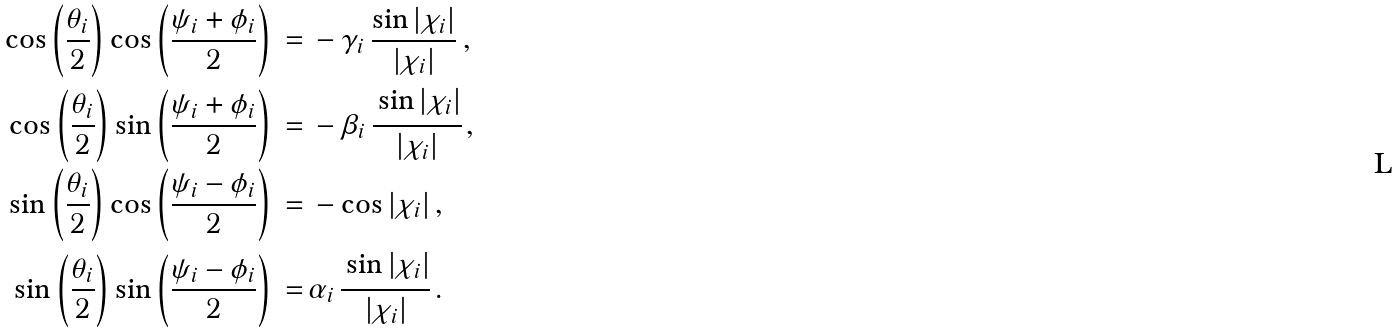<formula> <loc_0><loc_0><loc_500><loc_500>\cos \left ( \frac { \theta _ { i } } { 2 } \right ) \cos \left ( \frac { \psi _ { i } + \phi _ { i } } { 2 } \right ) \, = & \, - \gamma _ { i } \, \frac { \sin { | \chi _ { i } | } } { | \chi _ { i } | } \, , \\ \cos \left ( \frac { \theta _ { i } } { 2 } \right ) \sin \left ( \frac { \psi _ { i } + \phi _ { i } } { 2 } \right ) \, = & \, - \beta _ { i } \, \cfrac { \sin { | \chi _ { i } | } } { | \chi _ { i } | } \, , \\ \sin \left ( \frac { \theta _ { i } } { 2 } \right ) \cos \left ( \frac { \psi _ { i } - \phi _ { i } } { 2 } \right ) \, = & \, - \cos { | \chi _ { i } | } \, , \\ \sin \left ( \frac { \theta _ { i } } { 2 } \right ) \sin \left ( \frac { \psi _ { i } - \phi _ { i } } { 2 } \right ) \, = & \, \alpha _ { i } \, \cfrac { \sin { | \chi _ { i } | } } { | \chi _ { i } | } \, .</formula> 